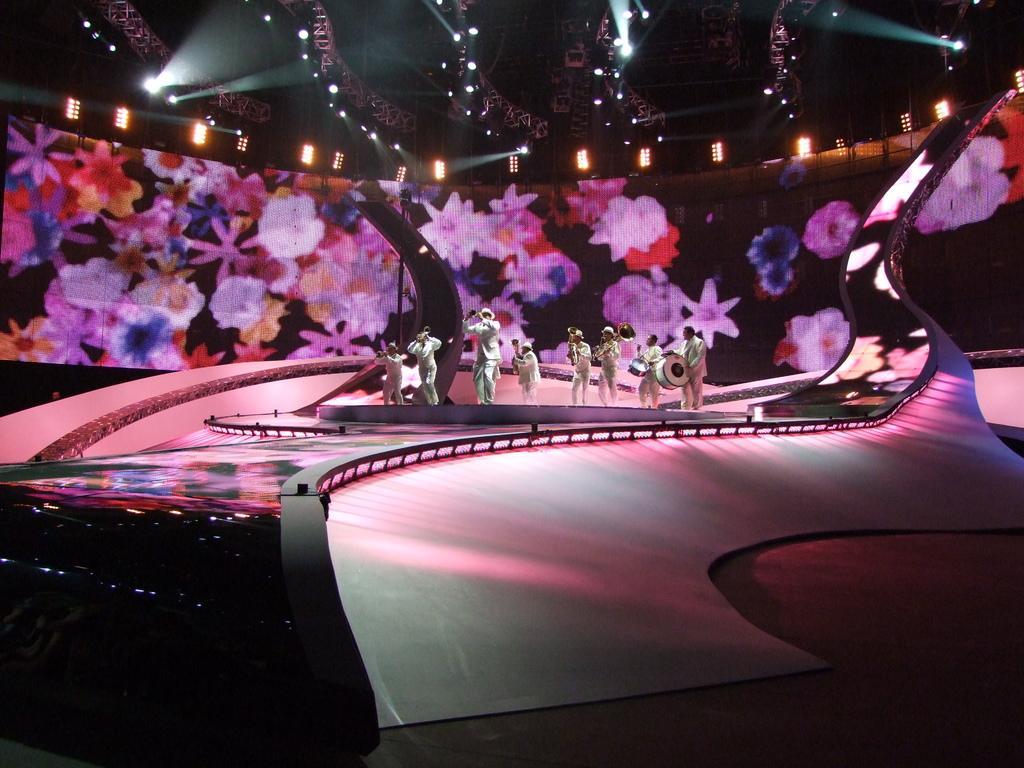In one or two sentences, can you explain what this image depicts? In this image, we can see a group of people standing and wearing clothes. There are two persons playing musical drums. There are some lights at the top of the image. 